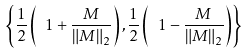<formula> <loc_0><loc_0><loc_500><loc_500>\left \{ \frac { 1 } { 2 } \left ( \ 1 + \frac { M } { \| M \| _ { 2 } } \right ) , \frac { 1 } { 2 } \left ( \ 1 - \frac { M } { \| M \| _ { 2 } } \right ) \right \}</formula> 